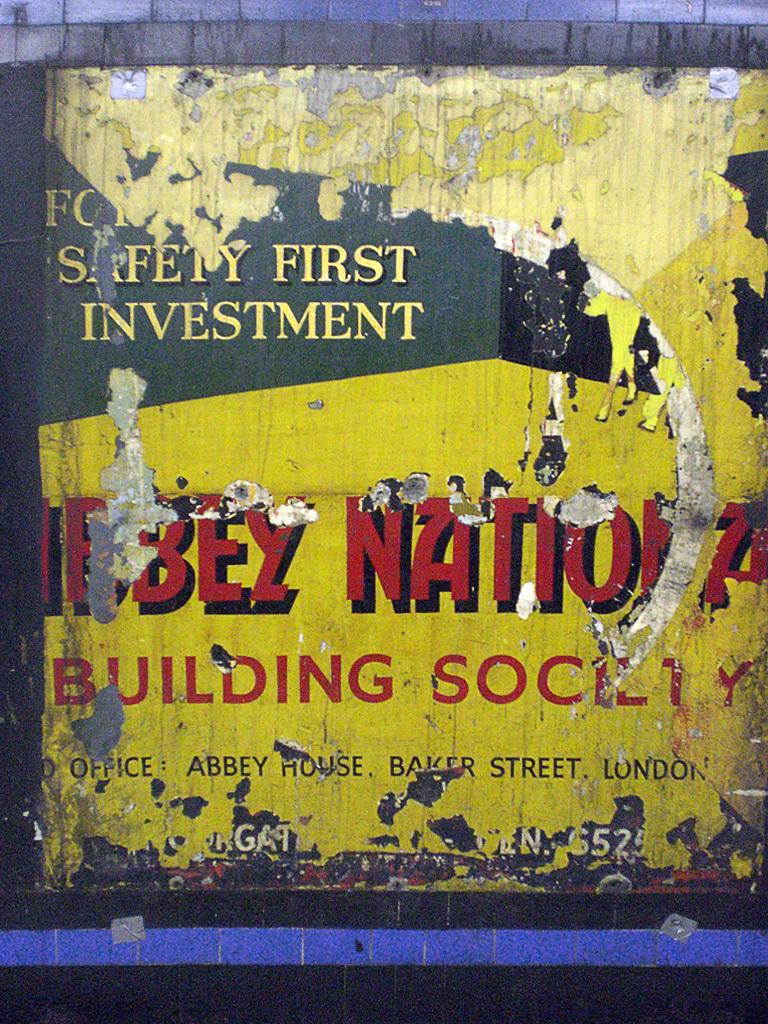What street is listed on this billboard?
Offer a terse response. Baker. Safety first what?
Your response must be concise. Investment. 